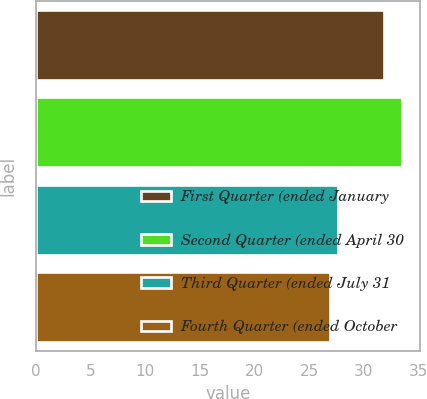Convert chart. <chart><loc_0><loc_0><loc_500><loc_500><bar_chart><fcel>First Quarter (ended January<fcel>Second Quarter (ended April 30<fcel>Third Quarter (ended July 31<fcel>Fourth Quarter (ended October<nl><fcel>31.9<fcel>33.52<fcel>27.62<fcel>26.96<nl></chart> 